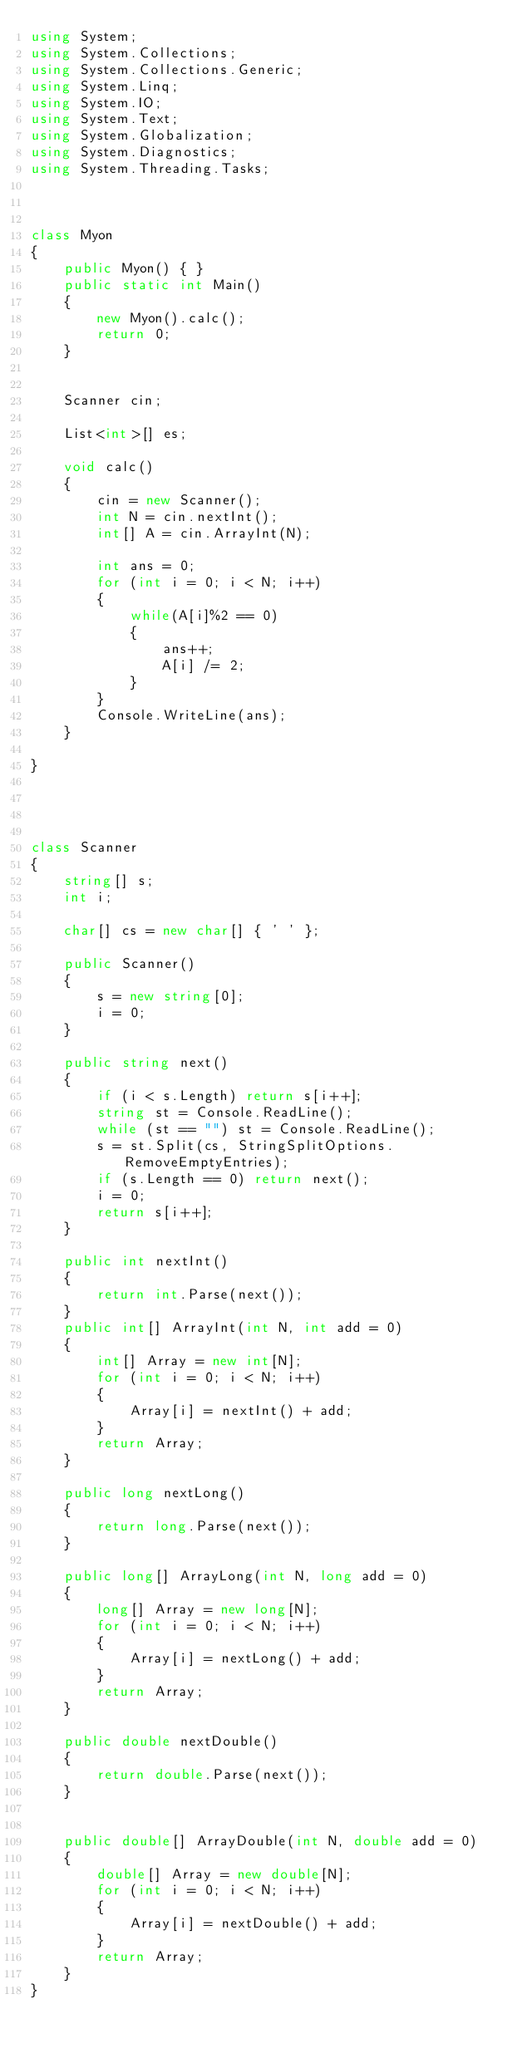<code> <loc_0><loc_0><loc_500><loc_500><_C#_>using System;
using System.Collections;
using System.Collections.Generic;
using System.Linq;
using System.IO;
using System.Text;
using System.Globalization;
using System.Diagnostics;
using System.Threading.Tasks;



class Myon
{
    public Myon() { }
    public static int Main()
    {
        new Myon().calc();
        return 0;
    }
    

    Scanner cin;

    List<int>[] es;

    void calc()
    {
        cin = new Scanner();
        int N = cin.nextInt();
        int[] A = cin.ArrayInt(N);

        int ans = 0;
        for (int i = 0; i < N; i++)
        {
            while(A[i]%2 == 0)
            {
                ans++;
                A[i] /= 2;
            }
        }
        Console.WriteLine(ans);
    }
    
}




class Scanner
{
    string[] s;
    int i;

    char[] cs = new char[] { ' ' };

    public Scanner()
    {
        s = new string[0];
        i = 0;
    }

    public string next()
    {
        if (i < s.Length) return s[i++];
        string st = Console.ReadLine();
        while (st == "") st = Console.ReadLine();
        s = st.Split(cs, StringSplitOptions.RemoveEmptyEntries);
        if (s.Length == 0) return next();
        i = 0;
        return s[i++];
    }

    public int nextInt()
    {
        return int.Parse(next());
    }
    public int[] ArrayInt(int N, int add = 0)
    {
        int[] Array = new int[N];
        for (int i = 0; i < N; i++)
        {
            Array[i] = nextInt() + add;
        }
        return Array;
    }

    public long nextLong()
    {
        return long.Parse(next());
    }

    public long[] ArrayLong(int N, long add = 0)
    {
        long[] Array = new long[N];
        for (int i = 0; i < N; i++)
        {
            Array[i] = nextLong() + add;
        }
        return Array;
    }

    public double nextDouble()
    {
        return double.Parse(next());
    }


    public double[] ArrayDouble(int N, double add = 0)
    {
        double[] Array = new double[N];
        for (int i = 0; i < N; i++)
        {
            Array[i] = nextDouble() + add;
        }
        return Array;
    }
}

</code> 